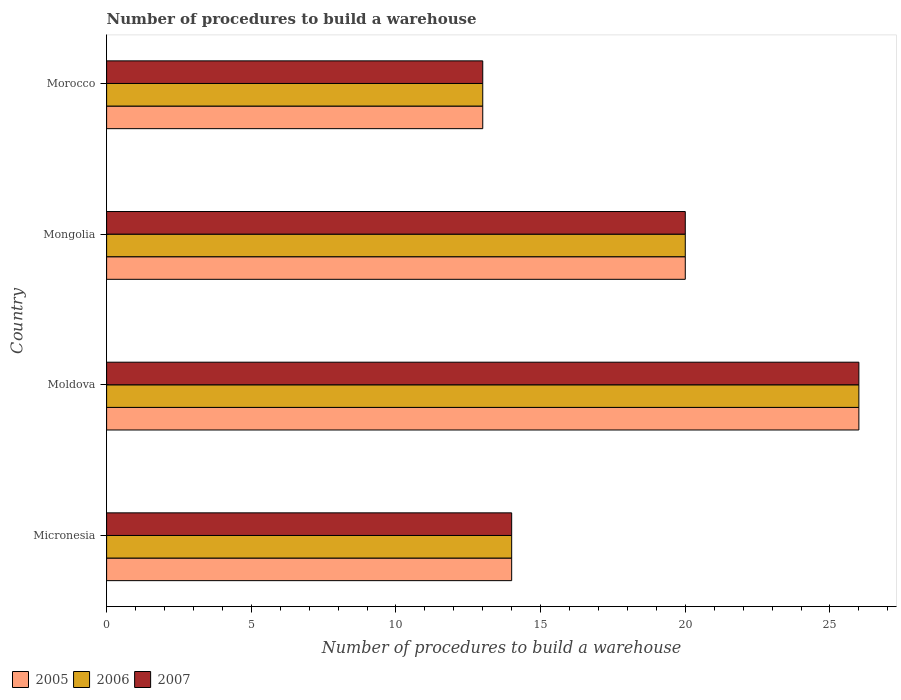How many different coloured bars are there?
Offer a very short reply. 3. How many bars are there on the 2nd tick from the top?
Offer a very short reply. 3. How many bars are there on the 4th tick from the bottom?
Keep it short and to the point. 3. What is the label of the 3rd group of bars from the top?
Your response must be concise. Moldova. In how many cases, is the number of bars for a given country not equal to the number of legend labels?
Give a very brief answer. 0. Across all countries, what is the maximum number of procedures to build a warehouse in in 2007?
Give a very brief answer. 26. Across all countries, what is the minimum number of procedures to build a warehouse in in 2007?
Give a very brief answer. 13. In which country was the number of procedures to build a warehouse in in 2007 maximum?
Your answer should be compact. Moldova. In which country was the number of procedures to build a warehouse in in 2006 minimum?
Make the answer very short. Morocco. What is the total number of procedures to build a warehouse in in 2006 in the graph?
Provide a succinct answer. 73. What is the average number of procedures to build a warehouse in in 2005 per country?
Offer a terse response. 18.25. What is the ratio of the number of procedures to build a warehouse in in 2005 in Micronesia to that in Morocco?
Keep it short and to the point. 1.08. Is the difference between the number of procedures to build a warehouse in in 2006 in Micronesia and Moldova greater than the difference between the number of procedures to build a warehouse in in 2007 in Micronesia and Moldova?
Offer a terse response. No. What is the difference between the highest and the second highest number of procedures to build a warehouse in in 2005?
Your answer should be compact. 6. What is the difference between the highest and the lowest number of procedures to build a warehouse in in 2007?
Keep it short and to the point. 13. Are all the bars in the graph horizontal?
Offer a terse response. Yes. What is the difference between two consecutive major ticks on the X-axis?
Make the answer very short. 5. Does the graph contain any zero values?
Ensure brevity in your answer.  No. Where does the legend appear in the graph?
Offer a very short reply. Bottom left. How many legend labels are there?
Provide a short and direct response. 3. What is the title of the graph?
Make the answer very short. Number of procedures to build a warehouse. Does "2011" appear as one of the legend labels in the graph?
Ensure brevity in your answer.  No. What is the label or title of the X-axis?
Provide a short and direct response. Number of procedures to build a warehouse. What is the Number of procedures to build a warehouse in 2007 in Micronesia?
Make the answer very short. 14. What is the Number of procedures to build a warehouse of 2006 in Moldova?
Provide a short and direct response. 26. What is the Number of procedures to build a warehouse in 2007 in Moldova?
Keep it short and to the point. 26. What is the Number of procedures to build a warehouse in 2005 in Mongolia?
Give a very brief answer. 20. What is the Number of procedures to build a warehouse in 2007 in Mongolia?
Your response must be concise. 20. What is the Number of procedures to build a warehouse in 2005 in Morocco?
Provide a succinct answer. 13. What is the Number of procedures to build a warehouse of 2007 in Morocco?
Ensure brevity in your answer.  13. Across all countries, what is the maximum Number of procedures to build a warehouse of 2006?
Ensure brevity in your answer.  26. Across all countries, what is the maximum Number of procedures to build a warehouse of 2007?
Keep it short and to the point. 26. What is the total Number of procedures to build a warehouse in 2005 in the graph?
Give a very brief answer. 73. What is the total Number of procedures to build a warehouse of 2007 in the graph?
Provide a succinct answer. 73. What is the difference between the Number of procedures to build a warehouse of 2005 in Micronesia and that in Moldova?
Your response must be concise. -12. What is the difference between the Number of procedures to build a warehouse in 2007 in Micronesia and that in Mongolia?
Your response must be concise. -6. What is the difference between the Number of procedures to build a warehouse of 2005 in Micronesia and that in Morocco?
Provide a succinct answer. 1. What is the difference between the Number of procedures to build a warehouse of 2007 in Micronesia and that in Morocco?
Offer a terse response. 1. What is the difference between the Number of procedures to build a warehouse of 2007 in Moldova and that in Mongolia?
Provide a succinct answer. 6. What is the difference between the Number of procedures to build a warehouse of 2006 in Moldova and that in Morocco?
Your answer should be compact. 13. What is the difference between the Number of procedures to build a warehouse in 2007 in Mongolia and that in Morocco?
Your answer should be very brief. 7. What is the difference between the Number of procedures to build a warehouse of 2005 in Micronesia and the Number of procedures to build a warehouse of 2006 in Moldova?
Provide a succinct answer. -12. What is the difference between the Number of procedures to build a warehouse in 2005 in Micronesia and the Number of procedures to build a warehouse in 2007 in Moldova?
Ensure brevity in your answer.  -12. What is the difference between the Number of procedures to build a warehouse in 2005 in Micronesia and the Number of procedures to build a warehouse in 2006 in Mongolia?
Give a very brief answer. -6. What is the difference between the Number of procedures to build a warehouse of 2006 in Micronesia and the Number of procedures to build a warehouse of 2007 in Mongolia?
Keep it short and to the point. -6. What is the difference between the Number of procedures to build a warehouse of 2005 in Micronesia and the Number of procedures to build a warehouse of 2006 in Morocco?
Keep it short and to the point. 1. What is the difference between the Number of procedures to build a warehouse in 2005 in Micronesia and the Number of procedures to build a warehouse in 2007 in Morocco?
Provide a succinct answer. 1. What is the difference between the Number of procedures to build a warehouse of 2005 in Moldova and the Number of procedures to build a warehouse of 2007 in Mongolia?
Your response must be concise. 6. What is the difference between the Number of procedures to build a warehouse in 2005 in Moldova and the Number of procedures to build a warehouse in 2006 in Morocco?
Your answer should be very brief. 13. What is the difference between the Number of procedures to build a warehouse in 2005 in Moldova and the Number of procedures to build a warehouse in 2007 in Morocco?
Ensure brevity in your answer.  13. What is the difference between the Number of procedures to build a warehouse of 2005 in Mongolia and the Number of procedures to build a warehouse of 2006 in Morocco?
Offer a terse response. 7. What is the difference between the Number of procedures to build a warehouse in 2005 in Mongolia and the Number of procedures to build a warehouse in 2007 in Morocco?
Make the answer very short. 7. What is the average Number of procedures to build a warehouse in 2005 per country?
Make the answer very short. 18.25. What is the average Number of procedures to build a warehouse of 2006 per country?
Ensure brevity in your answer.  18.25. What is the average Number of procedures to build a warehouse in 2007 per country?
Your answer should be very brief. 18.25. What is the difference between the Number of procedures to build a warehouse in 2005 and Number of procedures to build a warehouse in 2007 in Micronesia?
Provide a short and direct response. 0. What is the difference between the Number of procedures to build a warehouse in 2005 and Number of procedures to build a warehouse in 2006 in Moldova?
Your answer should be very brief. 0. What is the difference between the Number of procedures to build a warehouse in 2005 and Number of procedures to build a warehouse in 2007 in Moldova?
Your answer should be very brief. 0. What is the difference between the Number of procedures to build a warehouse in 2006 and Number of procedures to build a warehouse in 2007 in Mongolia?
Offer a very short reply. 0. What is the difference between the Number of procedures to build a warehouse in 2005 and Number of procedures to build a warehouse in 2006 in Morocco?
Give a very brief answer. 0. What is the difference between the Number of procedures to build a warehouse in 2006 and Number of procedures to build a warehouse in 2007 in Morocco?
Your answer should be very brief. 0. What is the ratio of the Number of procedures to build a warehouse in 2005 in Micronesia to that in Moldova?
Your answer should be compact. 0.54. What is the ratio of the Number of procedures to build a warehouse of 2006 in Micronesia to that in Moldova?
Your answer should be very brief. 0.54. What is the ratio of the Number of procedures to build a warehouse of 2007 in Micronesia to that in Moldova?
Ensure brevity in your answer.  0.54. What is the ratio of the Number of procedures to build a warehouse in 2007 in Micronesia to that in Mongolia?
Ensure brevity in your answer.  0.7. What is the ratio of the Number of procedures to build a warehouse of 2005 in Micronesia to that in Morocco?
Provide a short and direct response. 1.08. What is the ratio of the Number of procedures to build a warehouse in 2006 in Moldova to that in Mongolia?
Make the answer very short. 1.3. What is the ratio of the Number of procedures to build a warehouse of 2007 in Moldova to that in Mongolia?
Your response must be concise. 1.3. What is the ratio of the Number of procedures to build a warehouse of 2005 in Moldova to that in Morocco?
Ensure brevity in your answer.  2. What is the ratio of the Number of procedures to build a warehouse of 2006 in Moldova to that in Morocco?
Make the answer very short. 2. What is the ratio of the Number of procedures to build a warehouse of 2005 in Mongolia to that in Morocco?
Give a very brief answer. 1.54. What is the ratio of the Number of procedures to build a warehouse in 2006 in Mongolia to that in Morocco?
Provide a short and direct response. 1.54. What is the ratio of the Number of procedures to build a warehouse of 2007 in Mongolia to that in Morocco?
Provide a short and direct response. 1.54. What is the difference between the highest and the second highest Number of procedures to build a warehouse in 2005?
Give a very brief answer. 6. What is the difference between the highest and the lowest Number of procedures to build a warehouse in 2006?
Your response must be concise. 13. 